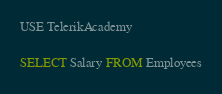<code> <loc_0><loc_0><loc_500><loc_500><_SQL_>USE TelerikAcademy

SELECT Salary FROM Employees</code> 